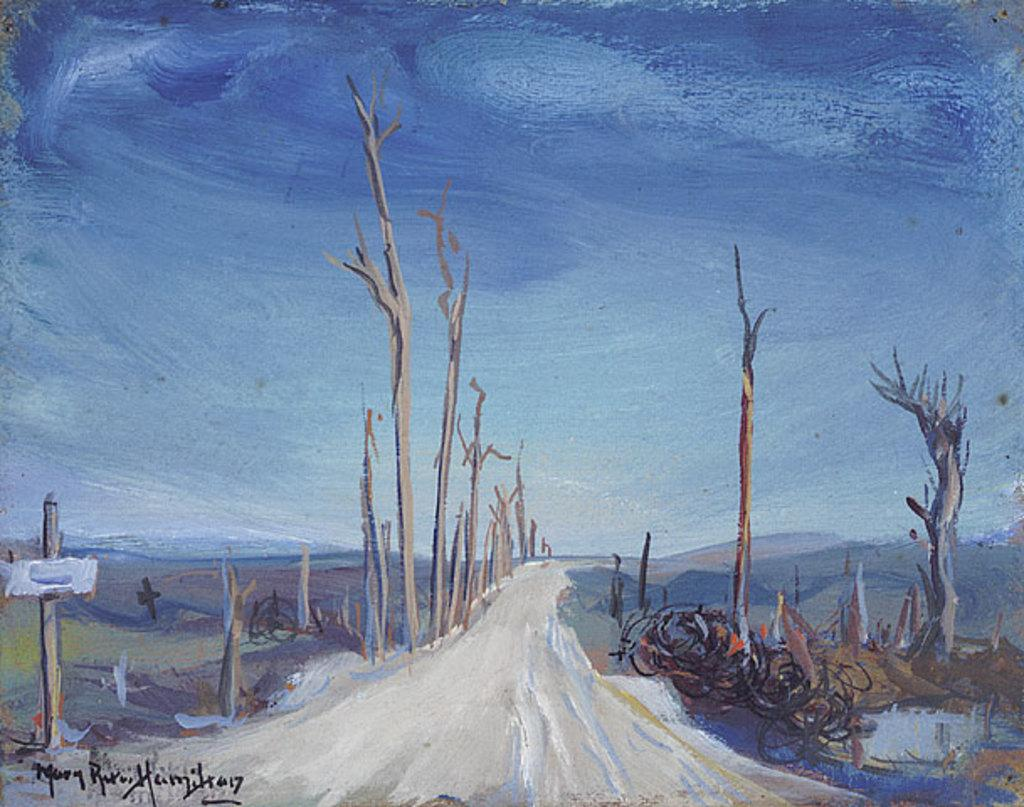What type of landscape is depicted in the painting? The painting contains trees, a road, and hills. What can be seen in the background of the painting? The sky is visible in the background of the painting. Where is the lunchroom located in the painting? There is no lunchroom present in the painting; it is a landscape painting featuring trees, a road, hills, and the sky. Can you see a swing in the painting? There is no swing present in the painting; it is a landscape painting featuring trees, a road, hills, and the sky. 